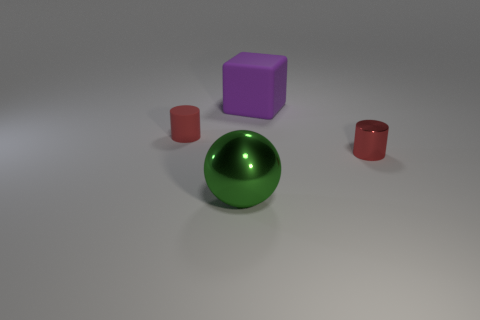Add 4 small cyan cylinders. How many objects exist? 8 Subtract all big cubes. Subtract all big metal cylinders. How many objects are left? 3 Add 3 large purple blocks. How many large purple blocks are left? 4 Add 2 tiny red rubber cylinders. How many tiny red rubber cylinders exist? 3 Subtract 1 green balls. How many objects are left? 3 Subtract all cubes. How many objects are left? 3 Subtract all gray cylinders. Subtract all red cubes. How many cylinders are left? 2 